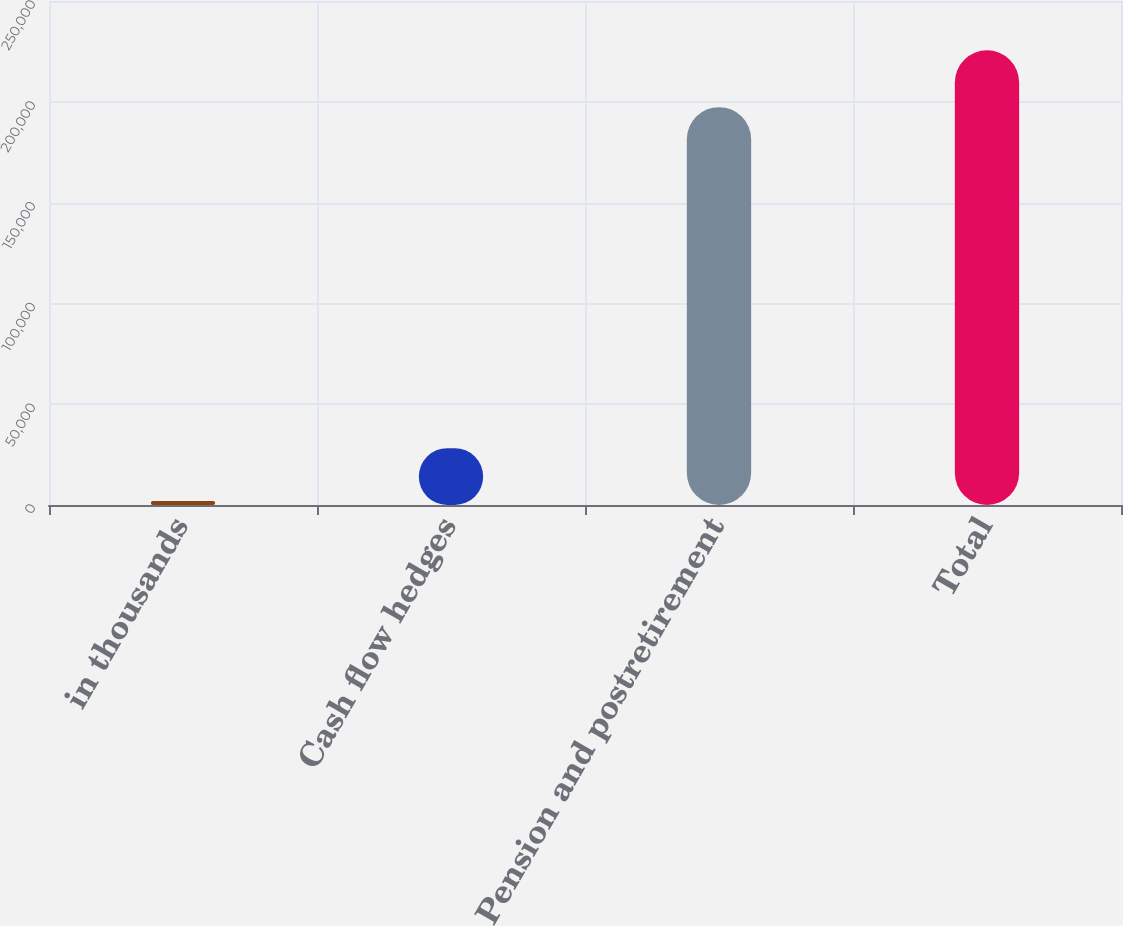Convert chart to OTSL. <chart><loc_0><loc_0><loc_500><loc_500><bar_chart><fcel>in thousands<fcel>Cash flow hedges<fcel>Pension and postretirement<fcel>Total<nl><fcel>2012<fcel>28170<fcel>197347<fcel>225517<nl></chart> 